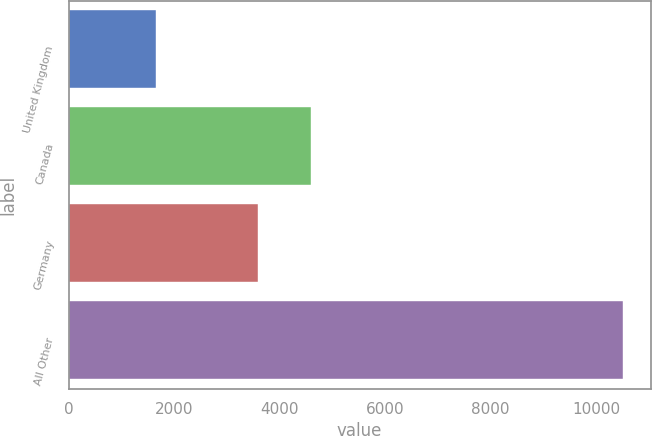Convert chart. <chart><loc_0><loc_0><loc_500><loc_500><bar_chart><fcel>United Kingdom<fcel>Canada<fcel>Germany<fcel>All Other<nl><fcel>1650<fcel>4604<fcel>3593<fcel>10510<nl></chart> 